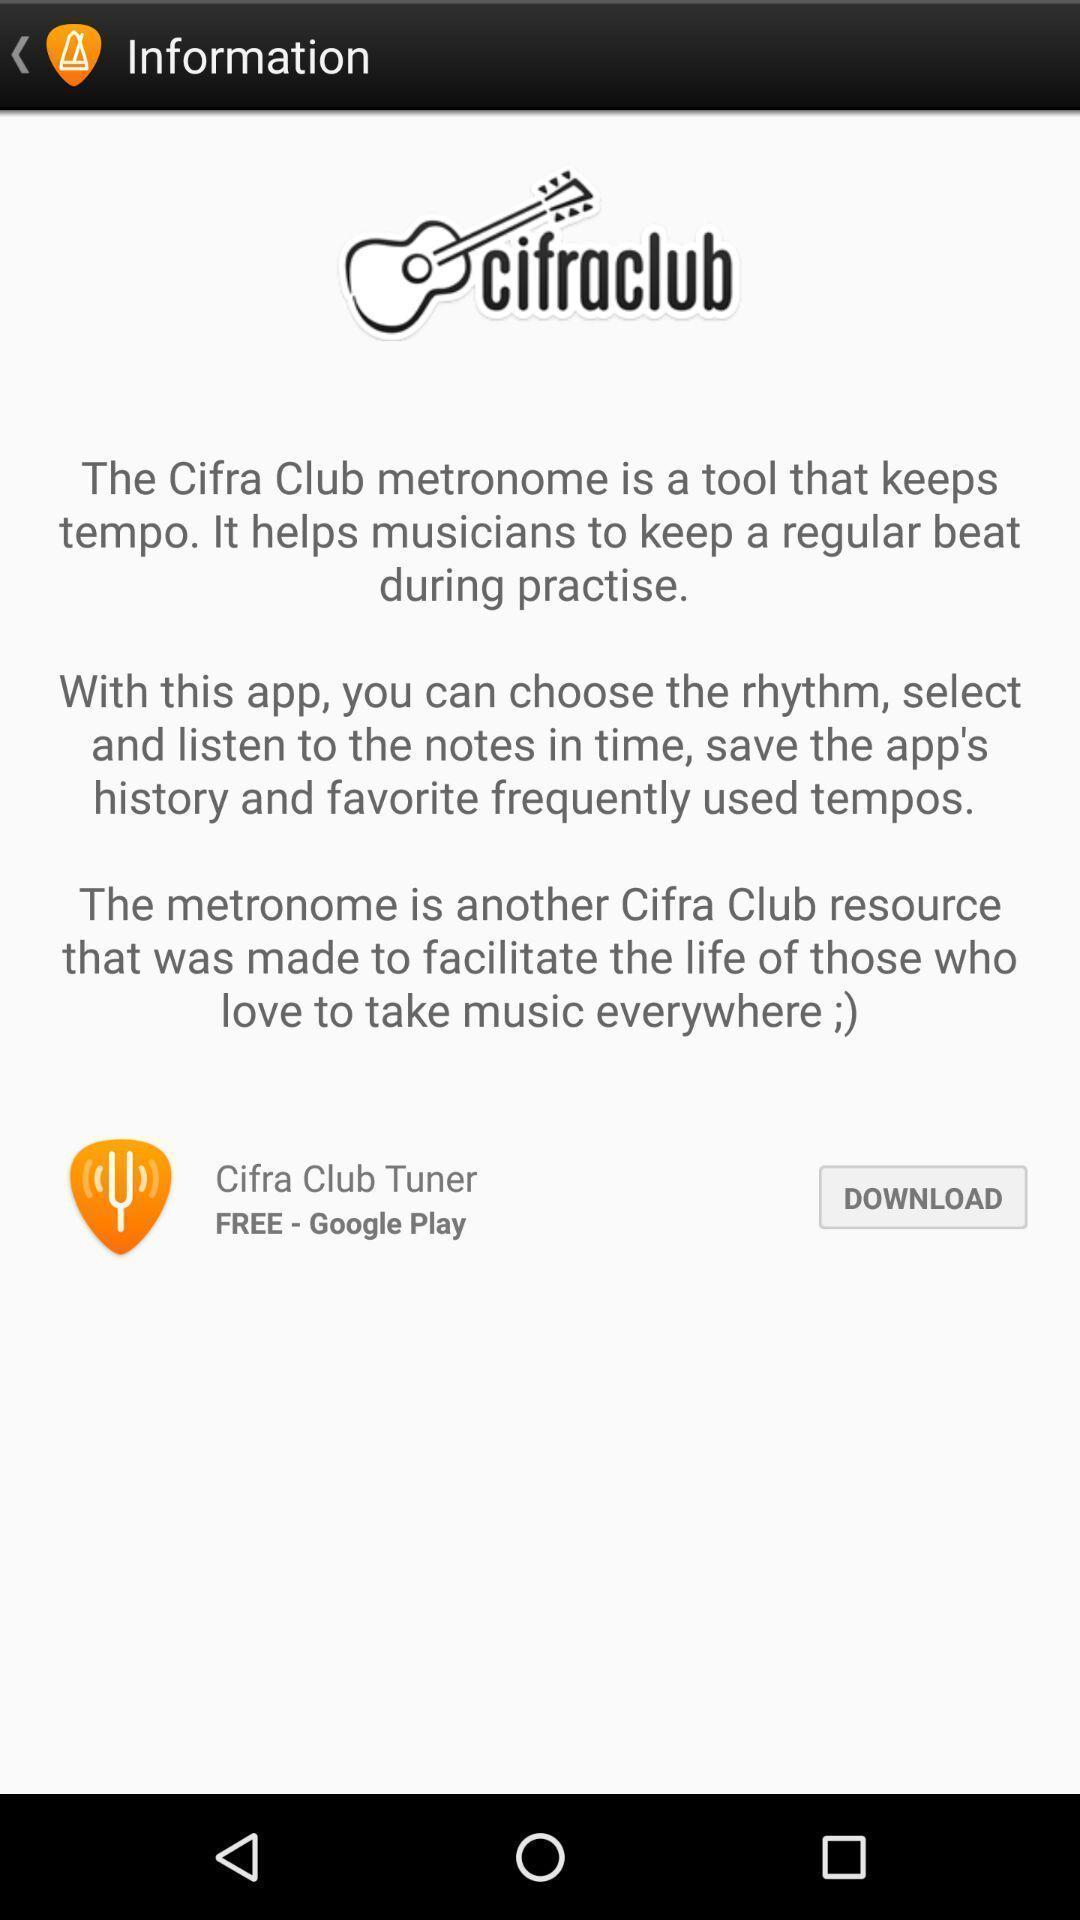Provide a description of this screenshot. Page giving information about music learning app. 